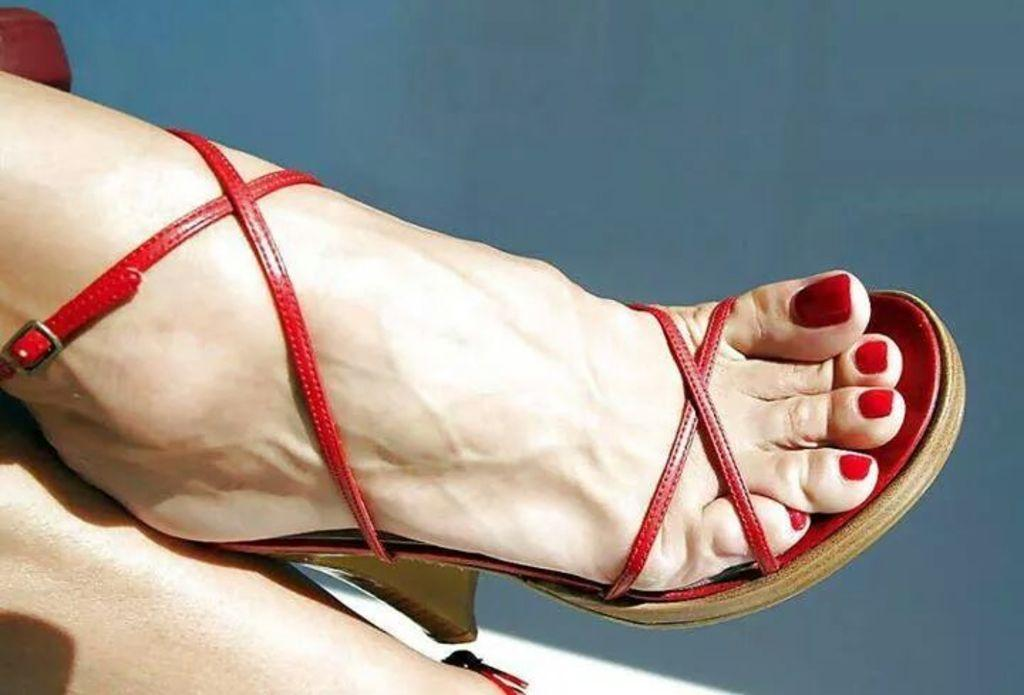What part of the body is visible in the image? There is a person's foot in the image. What is the foot wearing? The foot is wearing footwear. What color is the background of the image? The background of the image is blue. Can you see the person's heart beating in the image? There is no indication of a heart or its beating in the image, as it only shows a person's foot wearing footwear against a blue background. 